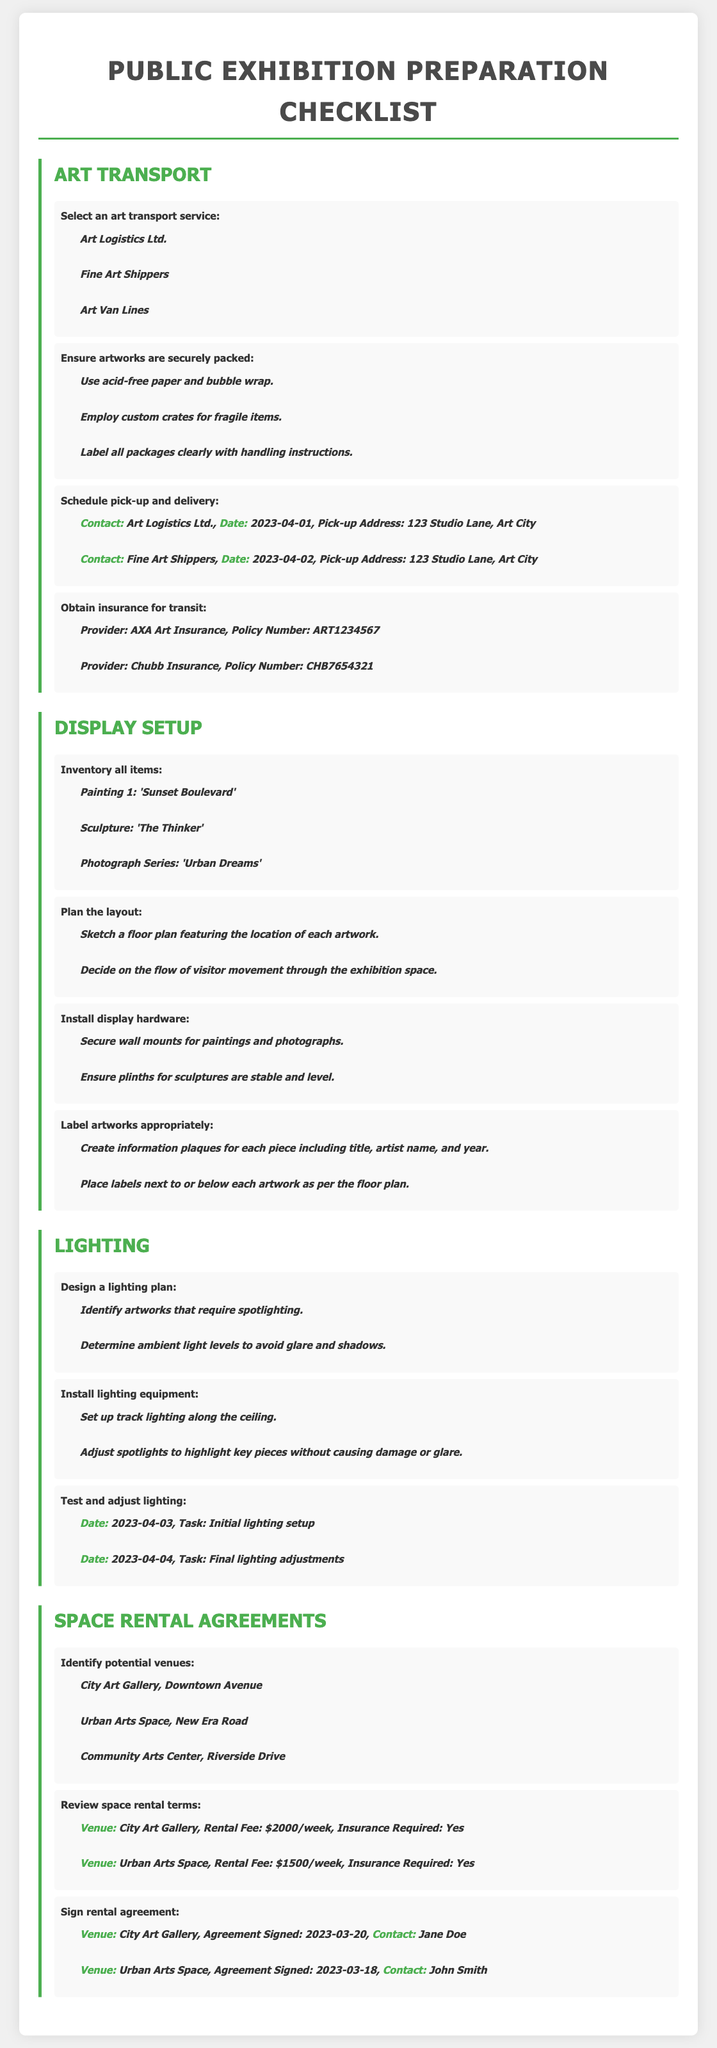what is the name of one art transport service? The document lists several art transport services including 'Art Logistics Ltd.'
Answer: Art Logistics Ltd what is the date for the initial lighting setup? The lighting tasks include a date for the initial lighting setup on 2023-04-03
Answer: 2023-04-03 how much is the rental fee for the Urban Arts Space? The document states the rental fee for Urban Arts Space is $1500/week
Answer: $1500/week who is the contact person for the City Art Gallery? The document mentions Jane Doe as the contact person for City Art Gallery
Answer: Jane Doe how many artworks are listed in the inventory? The display setup section includes three artworks in the inventory
Answer: 3 what type of paper should be used for packing artworks? The document specifies to use acid-free paper for securely packing artworks
Answer: acid-free paper where is the Community Arts Center located? The document lists the location of Community Arts Center as Riverside Drive
Answer: Riverside Drive who is the provider for the insurance policy number ART1234567? The insurance section of the document indicates that the provider for that policy number is AXA Art Insurance
Answer: AXA Art Insurance what is the title of the photograph series mentioned? The document lists 'Urban Dreams' as the title of the photograph series in the inventory
Answer: Urban Dreams 